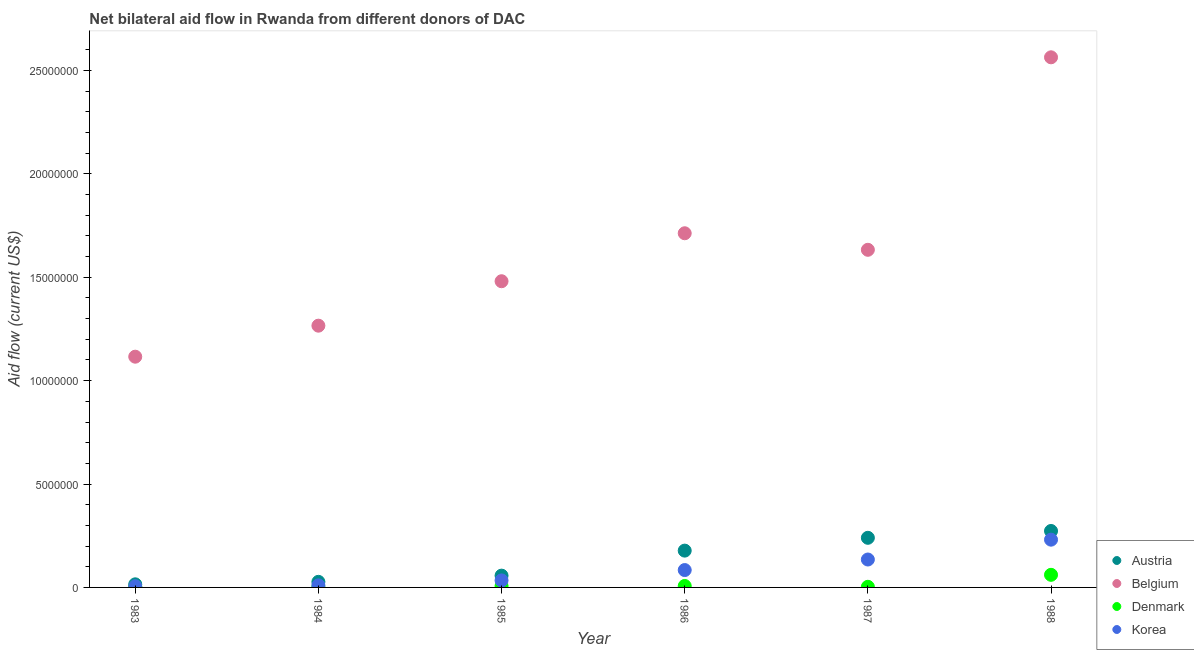Is the number of dotlines equal to the number of legend labels?
Make the answer very short. Yes. What is the amount of aid given by korea in 1985?
Provide a succinct answer. 3.40e+05. Across all years, what is the maximum amount of aid given by belgium?
Offer a terse response. 2.56e+07. Across all years, what is the minimum amount of aid given by korea?
Your answer should be very brief. 6.00e+04. In which year was the amount of aid given by austria maximum?
Keep it short and to the point. 1988. In which year was the amount of aid given by korea minimum?
Offer a terse response. 1983. What is the total amount of aid given by austria in the graph?
Your answer should be very brief. 7.90e+06. What is the difference between the amount of aid given by austria in 1984 and that in 1985?
Your answer should be very brief. -3.00e+05. What is the difference between the amount of aid given by denmark in 1987 and the amount of aid given by korea in 1986?
Your answer should be compact. -8.10e+05. What is the average amount of aid given by denmark per year?
Ensure brevity in your answer.  1.40e+05. In the year 1987, what is the difference between the amount of aid given by belgium and amount of aid given by denmark?
Provide a succinct answer. 1.63e+07. In how many years, is the amount of aid given by denmark greater than 18000000 US$?
Give a very brief answer. 0. What is the ratio of the amount of aid given by denmark in 1985 to that in 1988?
Give a very brief answer. 0.11. Is the difference between the amount of aid given by austria in 1983 and 1984 greater than the difference between the amount of aid given by belgium in 1983 and 1984?
Keep it short and to the point. Yes. What is the difference between the highest and the second highest amount of aid given by belgium?
Keep it short and to the point. 8.51e+06. What is the difference between the highest and the lowest amount of aid given by austria?
Provide a short and direct response. 2.58e+06. In how many years, is the amount of aid given by korea greater than the average amount of aid given by korea taken over all years?
Offer a terse response. 3. Is the amount of aid given by korea strictly greater than the amount of aid given by denmark over the years?
Provide a short and direct response. Yes. Does the graph contain grids?
Keep it short and to the point. No. Where does the legend appear in the graph?
Ensure brevity in your answer.  Bottom right. What is the title of the graph?
Ensure brevity in your answer.  Net bilateral aid flow in Rwanda from different donors of DAC. Does "Portugal" appear as one of the legend labels in the graph?
Your response must be concise. No. What is the label or title of the X-axis?
Your response must be concise. Year. What is the label or title of the Y-axis?
Make the answer very short. Aid flow (current US$). What is the Aid flow (current US$) of Belgium in 1983?
Provide a succinct answer. 1.12e+07. What is the Aid flow (current US$) in Denmark in 1983?
Your answer should be compact. 4.00e+04. What is the Aid flow (current US$) in Korea in 1983?
Offer a terse response. 6.00e+04. What is the Aid flow (current US$) of Austria in 1984?
Provide a short and direct response. 2.70e+05. What is the Aid flow (current US$) of Belgium in 1984?
Give a very brief answer. 1.27e+07. What is the Aid flow (current US$) in Denmark in 1984?
Provide a short and direct response. 2.00e+04. What is the Aid flow (current US$) of Austria in 1985?
Your answer should be very brief. 5.70e+05. What is the Aid flow (current US$) of Belgium in 1985?
Provide a short and direct response. 1.48e+07. What is the Aid flow (current US$) of Korea in 1985?
Your response must be concise. 3.40e+05. What is the Aid flow (current US$) in Austria in 1986?
Make the answer very short. 1.78e+06. What is the Aid flow (current US$) of Belgium in 1986?
Provide a succinct answer. 1.71e+07. What is the Aid flow (current US$) of Denmark in 1986?
Keep it short and to the point. 7.00e+04. What is the Aid flow (current US$) in Korea in 1986?
Provide a short and direct response. 8.40e+05. What is the Aid flow (current US$) of Austria in 1987?
Your answer should be compact. 2.40e+06. What is the Aid flow (current US$) in Belgium in 1987?
Provide a short and direct response. 1.63e+07. What is the Aid flow (current US$) in Korea in 1987?
Keep it short and to the point. 1.35e+06. What is the Aid flow (current US$) in Austria in 1988?
Your answer should be very brief. 2.73e+06. What is the Aid flow (current US$) in Belgium in 1988?
Your answer should be very brief. 2.56e+07. What is the Aid flow (current US$) in Denmark in 1988?
Offer a very short reply. 6.10e+05. What is the Aid flow (current US$) in Korea in 1988?
Provide a succinct answer. 2.31e+06. Across all years, what is the maximum Aid flow (current US$) of Austria?
Your answer should be compact. 2.73e+06. Across all years, what is the maximum Aid flow (current US$) of Belgium?
Offer a very short reply. 2.56e+07. Across all years, what is the maximum Aid flow (current US$) in Korea?
Provide a succinct answer. 2.31e+06. Across all years, what is the minimum Aid flow (current US$) of Belgium?
Your answer should be very brief. 1.12e+07. Across all years, what is the minimum Aid flow (current US$) in Denmark?
Provide a short and direct response. 2.00e+04. Across all years, what is the minimum Aid flow (current US$) of Korea?
Keep it short and to the point. 6.00e+04. What is the total Aid flow (current US$) of Austria in the graph?
Your answer should be very brief. 7.90e+06. What is the total Aid flow (current US$) of Belgium in the graph?
Make the answer very short. 9.77e+07. What is the total Aid flow (current US$) in Denmark in the graph?
Ensure brevity in your answer.  8.40e+05. What is the total Aid flow (current US$) in Korea in the graph?
Make the answer very short. 5.00e+06. What is the difference between the Aid flow (current US$) in Austria in 1983 and that in 1984?
Ensure brevity in your answer.  -1.20e+05. What is the difference between the Aid flow (current US$) of Belgium in 1983 and that in 1984?
Make the answer very short. -1.50e+06. What is the difference between the Aid flow (current US$) in Denmark in 1983 and that in 1984?
Your answer should be compact. 2.00e+04. What is the difference between the Aid flow (current US$) in Austria in 1983 and that in 1985?
Your response must be concise. -4.20e+05. What is the difference between the Aid flow (current US$) of Belgium in 1983 and that in 1985?
Provide a succinct answer. -3.65e+06. What is the difference between the Aid flow (current US$) in Korea in 1983 and that in 1985?
Give a very brief answer. -2.80e+05. What is the difference between the Aid flow (current US$) in Austria in 1983 and that in 1986?
Provide a short and direct response. -1.63e+06. What is the difference between the Aid flow (current US$) in Belgium in 1983 and that in 1986?
Ensure brevity in your answer.  -5.97e+06. What is the difference between the Aid flow (current US$) of Korea in 1983 and that in 1986?
Your answer should be compact. -7.80e+05. What is the difference between the Aid flow (current US$) of Austria in 1983 and that in 1987?
Your answer should be very brief. -2.25e+06. What is the difference between the Aid flow (current US$) of Belgium in 1983 and that in 1987?
Your answer should be compact. -5.17e+06. What is the difference between the Aid flow (current US$) of Korea in 1983 and that in 1987?
Provide a short and direct response. -1.29e+06. What is the difference between the Aid flow (current US$) in Austria in 1983 and that in 1988?
Your response must be concise. -2.58e+06. What is the difference between the Aid flow (current US$) of Belgium in 1983 and that in 1988?
Provide a short and direct response. -1.45e+07. What is the difference between the Aid flow (current US$) in Denmark in 1983 and that in 1988?
Make the answer very short. -5.70e+05. What is the difference between the Aid flow (current US$) in Korea in 1983 and that in 1988?
Provide a succinct answer. -2.25e+06. What is the difference between the Aid flow (current US$) in Austria in 1984 and that in 1985?
Provide a succinct answer. -3.00e+05. What is the difference between the Aid flow (current US$) in Belgium in 1984 and that in 1985?
Your response must be concise. -2.15e+06. What is the difference between the Aid flow (current US$) in Denmark in 1984 and that in 1985?
Give a very brief answer. -5.00e+04. What is the difference between the Aid flow (current US$) of Korea in 1984 and that in 1985?
Give a very brief answer. -2.40e+05. What is the difference between the Aid flow (current US$) of Austria in 1984 and that in 1986?
Offer a very short reply. -1.51e+06. What is the difference between the Aid flow (current US$) in Belgium in 1984 and that in 1986?
Keep it short and to the point. -4.47e+06. What is the difference between the Aid flow (current US$) in Denmark in 1984 and that in 1986?
Provide a short and direct response. -5.00e+04. What is the difference between the Aid flow (current US$) in Korea in 1984 and that in 1986?
Provide a short and direct response. -7.40e+05. What is the difference between the Aid flow (current US$) in Austria in 1984 and that in 1987?
Your answer should be compact. -2.13e+06. What is the difference between the Aid flow (current US$) in Belgium in 1984 and that in 1987?
Make the answer very short. -3.67e+06. What is the difference between the Aid flow (current US$) of Korea in 1984 and that in 1987?
Make the answer very short. -1.25e+06. What is the difference between the Aid flow (current US$) in Austria in 1984 and that in 1988?
Keep it short and to the point. -2.46e+06. What is the difference between the Aid flow (current US$) of Belgium in 1984 and that in 1988?
Offer a terse response. -1.30e+07. What is the difference between the Aid flow (current US$) in Denmark in 1984 and that in 1988?
Give a very brief answer. -5.90e+05. What is the difference between the Aid flow (current US$) in Korea in 1984 and that in 1988?
Make the answer very short. -2.21e+06. What is the difference between the Aid flow (current US$) of Austria in 1985 and that in 1986?
Keep it short and to the point. -1.21e+06. What is the difference between the Aid flow (current US$) of Belgium in 1985 and that in 1986?
Offer a terse response. -2.32e+06. What is the difference between the Aid flow (current US$) in Denmark in 1985 and that in 1986?
Your answer should be compact. 0. What is the difference between the Aid flow (current US$) of Korea in 1985 and that in 1986?
Ensure brevity in your answer.  -5.00e+05. What is the difference between the Aid flow (current US$) in Austria in 1985 and that in 1987?
Provide a succinct answer. -1.83e+06. What is the difference between the Aid flow (current US$) in Belgium in 1985 and that in 1987?
Your answer should be very brief. -1.52e+06. What is the difference between the Aid flow (current US$) in Denmark in 1985 and that in 1987?
Your answer should be very brief. 4.00e+04. What is the difference between the Aid flow (current US$) of Korea in 1985 and that in 1987?
Ensure brevity in your answer.  -1.01e+06. What is the difference between the Aid flow (current US$) in Austria in 1985 and that in 1988?
Your answer should be compact. -2.16e+06. What is the difference between the Aid flow (current US$) in Belgium in 1985 and that in 1988?
Provide a short and direct response. -1.08e+07. What is the difference between the Aid flow (current US$) in Denmark in 1985 and that in 1988?
Provide a succinct answer. -5.40e+05. What is the difference between the Aid flow (current US$) of Korea in 1985 and that in 1988?
Give a very brief answer. -1.97e+06. What is the difference between the Aid flow (current US$) in Austria in 1986 and that in 1987?
Provide a short and direct response. -6.20e+05. What is the difference between the Aid flow (current US$) of Belgium in 1986 and that in 1987?
Make the answer very short. 8.00e+05. What is the difference between the Aid flow (current US$) of Denmark in 1986 and that in 1987?
Make the answer very short. 4.00e+04. What is the difference between the Aid flow (current US$) of Korea in 1986 and that in 1987?
Your answer should be compact. -5.10e+05. What is the difference between the Aid flow (current US$) in Austria in 1986 and that in 1988?
Your response must be concise. -9.50e+05. What is the difference between the Aid flow (current US$) in Belgium in 1986 and that in 1988?
Offer a terse response. -8.51e+06. What is the difference between the Aid flow (current US$) in Denmark in 1986 and that in 1988?
Ensure brevity in your answer.  -5.40e+05. What is the difference between the Aid flow (current US$) of Korea in 1986 and that in 1988?
Provide a short and direct response. -1.47e+06. What is the difference between the Aid flow (current US$) of Austria in 1987 and that in 1988?
Make the answer very short. -3.30e+05. What is the difference between the Aid flow (current US$) in Belgium in 1987 and that in 1988?
Your answer should be very brief. -9.31e+06. What is the difference between the Aid flow (current US$) in Denmark in 1987 and that in 1988?
Provide a short and direct response. -5.80e+05. What is the difference between the Aid flow (current US$) in Korea in 1987 and that in 1988?
Make the answer very short. -9.60e+05. What is the difference between the Aid flow (current US$) in Austria in 1983 and the Aid flow (current US$) in Belgium in 1984?
Your answer should be very brief. -1.25e+07. What is the difference between the Aid flow (current US$) of Belgium in 1983 and the Aid flow (current US$) of Denmark in 1984?
Your answer should be compact. 1.11e+07. What is the difference between the Aid flow (current US$) in Belgium in 1983 and the Aid flow (current US$) in Korea in 1984?
Your response must be concise. 1.11e+07. What is the difference between the Aid flow (current US$) of Austria in 1983 and the Aid flow (current US$) of Belgium in 1985?
Your response must be concise. -1.47e+07. What is the difference between the Aid flow (current US$) of Belgium in 1983 and the Aid flow (current US$) of Denmark in 1985?
Your response must be concise. 1.11e+07. What is the difference between the Aid flow (current US$) of Belgium in 1983 and the Aid flow (current US$) of Korea in 1985?
Offer a terse response. 1.08e+07. What is the difference between the Aid flow (current US$) of Austria in 1983 and the Aid flow (current US$) of Belgium in 1986?
Keep it short and to the point. -1.70e+07. What is the difference between the Aid flow (current US$) in Austria in 1983 and the Aid flow (current US$) in Korea in 1986?
Keep it short and to the point. -6.90e+05. What is the difference between the Aid flow (current US$) of Belgium in 1983 and the Aid flow (current US$) of Denmark in 1986?
Give a very brief answer. 1.11e+07. What is the difference between the Aid flow (current US$) in Belgium in 1983 and the Aid flow (current US$) in Korea in 1986?
Ensure brevity in your answer.  1.03e+07. What is the difference between the Aid flow (current US$) in Denmark in 1983 and the Aid flow (current US$) in Korea in 1986?
Your answer should be compact. -8.00e+05. What is the difference between the Aid flow (current US$) in Austria in 1983 and the Aid flow (current US$) in Belgium in 1987?
Provide a succinct answer. -1.62e+07. What is the difference between the Aid flow (current US$) of Austria in 1983 and the Aid flow (current US$) of Denmark in 1987?
Offer a terse response. 1.20e+05. What is the difference between the Aid flow (current US$) in Austria in 1983 and the Aid flow (current US$) in Korea in 1987?
Keep it short and to the point. -1.20e+06. What is the difference between the Aid flow (current US$) in Belgium in 1983 and the Aid flow (current US$) in Denmark in 1987?
Provide a succinct answer. 1.11e+07. What is the difference between the Aid flow (current US$) of Belgium in 1983 and the Aid flow (current US$) of Korea in 1987?
Your answer should be very brief. 9.81e+06. What is the difference between the Aid flow (current US$) of Denmark in 1983 and the Aid flow (current US$) of Korea in 1987?
Your response must be concise. -1.31e+06. What is the difference between the Aid flow (current US$) of Austria in 1983 and the Aid flow (current US$) of Belgium in 1988?
Keep it short and to the point. -2.55e+07. What is the difference between the Aid flow (current US$) of Austria in 1983 and the Aid flow (current US$) of Denmark in 1988?
Your response must be concise. -4.60e+05. What is the difference between the Aid flow (current US$) of Austria in 1983 and the Aid flow (current US$) of Korea in 1988?
Ensure brevity in your answer.  -2.16e+06. What is the difference between the Aid flow (current US$) of Belgium in 1983 and the Aid flow (current US$) of Denmark in 1988?
Your answer should be compact. 1.06e+07. What is the difference between the Aid flow (current US$) of Belgium in 1983 and the Aid flow (current US$) of Korea in 1988?
Keep it short and to the point. 8.85e+06. What is the difference between the Aid flow (current US$) of Denmark in 1983 and the Aid flow (current US$) of Korea in 1988?
Ensure brevity in your answer.  -2.27e+06. What is the difference between the Aid flow (current US$) in Austria in 1984 and the Aid flow (current US$) in Belgium in 1985?
Ensure brevity in your answer.  -1.45e+07. What is the difference between the Aid flow (current US$) in Belgium in 1984 and the Aid flow (current US$) in Denmark in 1985?
Provide a succinct answer. 1.26e+07. What is the difference between the Aid flow (current US$) in Belgium in 1984 and the Aid flow (current US$) in Korea in 1985?
Offer a terse response. 1.23e+07. What is the difference between the Aid flow (current US$) of Denmark in 1984 and the Aid flow (current US$) of Korea in 1985?
Your response must be concise. -3.20e+05. What is the difference between the Aid flow (current US$) of Austria in 1984 and the Aid flow (current US$) of Belgium in 1986?
Make the answer very short. -1.69e+07. What is the difference between the Aid flow (current US$) of Austria in 1984 and the Aid flow (current US$) of Korea in 1986?
Give a very brief answer. -5.70e+05. What is the difference between the Aid flow (current US$) of Belgium in 1984 and the Aid flow (current US$) of Denmark in 1986?
Give a very brief answer. 1.26e+07. What is the difference between the Aid flow (current US$) of Belgium in 1984 and the Aid flow (current US$) of Korea in 1986?
Provide a short and direct response. 1.18e+07. What is the difference between the Aid flow (current US$) in Denmark in 1984 and the Aid flow (current US$) in Korea in 1986?
Your answer should be very brief. -8.20e+05. What is the difference between the Aid flow (current US$) in Austria in 1984 and the Aid flow (current US$) in Belgium in 1987?
Make the answer very short. -1.61e+07. What is the difference between the Aid flow (current US$) in Austria in 1984 and the Aid flow (current US$) in Denmark in 1987?
Your answer should be compact. 2.40e+05. What is the difference between the Aid flow (current US$) of Austria in 1984 and the Aid flow (current US$) of Korea in 1987?
Your response must be concise. -1.08e+06. What is the difference between the Aid flow (current US$) of Belgium in 1984 and the Aid flow (current US$) of Denmark in 1987?
Ensure brevity in your answer.  1.26e+07. What is the difference between the Aid flow (current US$) of Belgium in 1984 and the Aid flow (current US$) of Korea in 1987?
Offer a terse response. 1.13e+07. What is the difference between the Aid flow (current US$) in Denmark in 1984 and the Aid flow (current US$) in Korea in 1987?
Ensure brevity in your answer.  -1.33e+06. What is the difference between the Aid flow (current US$) in Austria in 1984 and the Aid flow (current US$) in Belgium in 1988?
Give a very brief answer. -2.54e+07. What is the difference between the Aid flow (current US$) in Austria in 1984 and the Aid flow (current US$) in Denmark in 1988?
Ensure brevity in your answer.  -3.40e+05. What is the difference between the Aid flow (current US$) of Austria in 1984 and the Aid flow (current US$) of Korea in 1988?
Your answer should be very brief. -2.04e+06. What is the difference between the Aid flow (current US$) of Belgium in 1984 and the Aid flow (current US$) of Denmark in 1988?
Offer a very short reply. 1.20e+07. What is the difference between the Aid flow (current US$) in Belgium in 1984 and the Aid flow (current US$) in Korea in 1988?
Make the answer very short. 1.04e+07. What is the difference between the Aid flow (current US$) in Denmark in 1984 and the Aid flow (current US$) in Korea in 1988?
Give a very brief answer. -2.29e+06. What is the difference between the Aid flow (current US$) of Austria in 1985 and the Aid flow (current US$) of Belgium in 1986?
Your answer should be very brief. -1.66e+07. What is the difference between the Aid flow (current US$) in Austria in 1985 and the Aid flow (current US$) in Denmark in 1986?
Provide a succinct answer. 5.00e+05. What is the difference between the Aid flow (current US$) in Belgium in 1985 and the Aid flow (current US$) in Denmark in 1986?
Make the answer very short. 1.47e+07. What is the difference between the Aid flow (current US$) of Belgium in 1985 and the Aid flow (current US$) of Korea in 1986?
Make the answer very short. 1.40e+07. What is the difference between the Aid flow (current US$) in Denmark in 1985 and the Aid flow (current US$) in Korea in 1986?
Provide a short and direct response. -7.70e+05. What is the difference between the Aid flow (current US$) of Austria in 1985 and the Aid flow (current US$) of Belgium in 1987?
Offer a very short reply. -1.58e+07. What is the difference between the Aid flow (current US$) in Austria in 1985 and the Aid flow (current US$) in Denmark in 1987?
Make the answer very short. 5.40e+05. What is the difference between the Aid flow (current US$) in Austria in 1985 and the Aid flow (current US$) in Korea in 1987?
Offer a very short reply. -7.80e+05. What is the difference between the Aid flow (current US$) in Belgium in 1985 and the Aid flow (current US$) in Denmark in 1987?
Keep it short and to the point. 1.48e+07. What is the difference between the Aid flow (current US$) of Belgium in 1985 and the Aid flow (current US$) of Korea in 1987?
Give a very brief answer. 1.35e+07. What is the difference between the Aid flow (current US$) of Denmark in 1985 and the Aid flow (current US$) of Korea in 1987?
Keep it short and to the point. -1.28e+06. What is the difference between the Aid flow (current US$) in Austria in 1985 and the Aid flow (current US$) in Belgium in 1988?
Keep it short and to the point. -2.51e+07. What is the difference between the Aid flow (current US$) in Austria in 1985 and the Aid flow (current US$) in Denmark in 1988?
Your answer should be very brief. -4.00e+04. What is the difference between the Aid flow (current US$) of Austria in 1985 and the Aid flow (current US$) of Korea in 1988?
Keep it short and to the point. -1.74e+06. What is the difference between the Aid flow (current US$) of Belgium in 1985 and the Aid flow (current US$) of Denmark in 1988?
Offer a very short reply. 1.42e+07. What is the difference between the Aid flow (current US$) in Belgium in 1985 and the Aid flow (current US$) in Korea in 1988?
Offer a very short reply. 1.25e+07. What is the difference between the Aid flow (current US$) in Denmark in 1985 and the Aid flow (current US$) in Korea in 1988?
Give a very brief answer. -2.24e+06. What is the difference between the Aid flow (current US$) in Austria in 1986 and the Aid flow (current US$) in Belgium in 1987?
Your response must be concise. -1.46e+07. What is the difference between the Aid flow (current US$) in Austria in 1986 and the Aid flow (current US$) in Denmark in 1987?
Offer a terse response. 1.75e+06. What is the difference between the Aid flow (current US$) of Belgium in 1986 and the Aid flow (current US$) of Denmark in 1987?
Make the answer very short. 1.71e+07. What is the difference between the Aid flow (current US$) of Belgium in 1986 and the Aid flow (current US$) of Korea in 1987?
Your answer should be compact. 1.58e+07. What is the difference between the Aid flow (current US$) of Denmark in 1986 and the Aid flow (current US$) of Korea in 1987?
Provide a succinct answer. -1.28e+06. What is the difference between the Aid flow (current US$) in Austria in 1986 and the Aid flow (current US$) in Belgium in 1988?
Offer a very short reply. -2.39e+07. What is the difference between the Aid flow (current US$) of Austria in 1986 and the Aid flow (current US$) of Denmark in 1988?
Your answer should be compact. 1.17e+06. What is the difference between the Aid flow (current US$) of Austria in 1986 and the Aid flow (current US$) of Korea in 1988?
Offer a very short reply. -5.30e+05. What is the difference between the Aid flow (current US$) in Belgium in 1986 and the Aid flow (current US$) in Denmark in 1988?
Your response must be concise. 1.65e+07. What is the difference between the Aid flow (current US$) in Belgium in 1986 and the Aid flow (current US$) in Korea in 1988?
Your response must be concise. 1.48e+07. What is the difference between the Aid flow (current US$) of Denmark in 1986 and the Aid flow (current US$) of Korea in 1988?
Provide a short and direct response. -2.24e+06. What is the difference between the Aid flow (current US$) in Austria in 1987 and the Aid flow (current US$) in Belgium in 1988?
Provide a succinct answer. -2.32e+07. What is the difference between the Aid flow (current US$) in Austria in 1987 and the Aid flow (current US$) in Denmark in 1988?
Your response must be concise. 1.79e+06. What is the difference between the Aid flow (current US$) of Belgium in 1987 and the Aid flow (current US$) of Denmark in 1988?
Ensure brevity in your answer.  1.57e+07. What is the difference between the Aid flow (current US$) of Belgium in 1987 and the Aid flow (current US$) of Korea in 1988?
Your answer should be compact. 1.40e+07. What is the difference between the Aid flow (current US$) in Denmark in 1987 and the Aid flow (current US$) in Korea in 1988?
Your answer should be compact. -2.28e+06. What is the average Aid flow (current US$) in Austria per year?
Ensure brevity in your answer.  1.32e+06. What is the average Aid flow (current US$) of Belgium per year?
Make the answer very short. 1.63e+07. What is the average Aid flow (current US$) in Denmark per year?
Provide a succinct answer. 1.40e+05. What is the average Aid flow (current US$) of Korea per year?
Your answer should be compact. 8.33e+05. In the year 1983, what is the difference between the Aid flow (current US$) in Austria and Aid flow (current US$) in Belgium?
Offer a terse response. -1.10e+07. In the year 1983, what is the difference between the Aid flow (current US$) in Austria and Aid flow (current US$) in Denmark?
Make the answer very short. 1.10e+05. In the year 1983, what is the difference between the Aid flow (current US$) in Austria and Aid flow (current US$) in Korea?
Your answer should be very brief. 9.00e+04. In the year 1983, what is the difference between the Aid flow (current US$) in Belgium and Aid flow (current US$) in Denmark?
Provide a succinct answer. 1.11e+07. In the year 1983, what is the difference between the Aid flow (current US$) of Belgium and Aid flow (current US$) of Korea?
Offer a very short reply. 1.11e+07. In the year 1983, what is the difference between the Aid flow (current US$) of Denmark and Aid flow (current US$) of Korea?
Your answer should be very brief. -2.00e+04. In the year 1984, what is the difference between the Aid flow (current US$) of Austria and Aid flow (current US$) of Belgium?
Provide a short and direct response. -1.24e+07. In the year 1984, what is the difference between the Aid flow (current US$) in Austria and Aid flow (current US$) in Denmark?
Offer a very short reply. 2.50e+05. In the year 1984, what is the difference between the Aid flow (current US$) of Belgium and Aid flow (current US$) of Denmark?
Offer a terse response. 1.26e+07. In the year 1984, what is the difference between the Aid flow (current US$) of Belgium and Aid flow (current US$) of Korea?
Offer a very short reply. 1.26e+07. In the year 1984, what is the difference between the Aid flow (current US$) in Denmark and Aid flow (current US$) in Korea?
Offer a very short reply. -8.00e+04. In the year 1985, what is the difference between the Aid flow (current US$) of Austria and Aid flow (current US$) of Belgium?
Make the answer very short. -1.42e+07. In the year 1985, what is the difference between the Aid flow (current US$) in Belgium and Aid flow (current US$) in Denmark?
Your answer should be compact. 1.47e+07. In the year 1985, what is the difference between the Aid flow (current US$) of Belgium and Aid flow (current US$) of Korea?
Your answer should be very brief. 1.45e+07. In the year 1986, what is the difference between the Aid flow (current US$) of Austria and Aid flow (current US$) of Belgium?
Ensure brevity in your answer.  -1.54e+07. In the year 1986, what is the difference between the Aid flow (current US$) in Austria and Aid flow (current US$) in Denmark?
Make the answer very short. 1.71e+06. In the year 1986, what is the difference between the Aid flow (current US$) of Austria and Aid flow (current US$) of Korea?
Offer a very short reply. 9.40e+05. In the year 1986, what is the difference between the Aid flow (current US$) in Belgium and Aid flow (current US$) in Denmark?
Provide a short and direct response. 1.71e+07. In the year 1986, what is the difference between the Aid flow (current US$) in Belgium and Aid flow (current US$) in Korea?
Your answer should be very brief. 1.63e+07. In the year 1986, what is the difference between the Aid flow (current US$) in Denmark and Aid flow (current US$) in Korea?
Provide a short and direct response. -7.70e+05. In the year 1987, what is the difference between the Aid flow (current US$) in Austria and Aid flow (current US$) in Belgium?
Offer a terse response. -1.39e+07. In the year 1987, what is the difference between the Aid flow (current US$) in Austria and Aid flow (current US$) in Denmark?
Your answer should be compact. 2.37e+06. In the year 1987, what is the difference between the Aid flow (current US$) of Austria and Aid flow (current US$) of Korea?
Offer a very short reply. 1.05e+06. In the year 1987, what is the difference between the Aid flow (current US$) in Belgium and Aid flow (current US$) in Denmark?
Your answer should be compact. 1.63e+07. In the year 1987, what is the difference between the Aid flow (current US$) of Belgium and Aid flow (current US$) of Korea?
Your response must be concise. 1.50e+07. In the year 1987, what is the difference between the Aid flow (current US$) of Denmark and Aid flow (current US$) of Korea?
Offer a very short reply. -1.32e+06. In the year 1988, what is the difference between the Aid flow (current US$) of Austria and Aid flow (current US$) of Belgium?
Your answer should be very brief. -2.29e+07. In the year 1988, what is the difference between the Aid flow (current US$) of Austria and Aid flow (current US$) of Denmark?
Keep it short and to the point. 2.12e+06. In the year 1988, what is the difference between the Aid flow (current US$) of Belgium and Aid flow (current US$) of Denmark?
Your answer should be very brief. 2.50e+07. In the year 1988, what is the difference between the Aid flow (current US$) of Belgium and Aid flow (current US$) of Korea?
Keep it short and to the point. 2.33e+07. In the year 1988, what is the difference between the Aid flow (current US$) in Denmark and Aid flow (current US$) in Korea?
Your answer should be compact. -1.70e+06. What is the ratio of the Aid flow (current US$) of Austria in 1983 to that in 1984?
Keep it short and to the point. 0.56. What is the ratio of the Aid flow (current US$) of Belgium in 1983 to that in 1984?
Your answer should be very brief. 0.88. What is the ratio of the Aid flow (current US$) in Korea in 1983 to that in 1984?
Offer a very short reply. 0.6. What is the ratio of the Aid flow (current US$) of Austria in 1983 to that in 1985?
Ensure brevity in your answer.  0.26. What is the ratio of the Aid flow (current US$) of Belgium in 1983 to that in 1985?
Make the answer very short. 0.75. What is the ratio of the Aid flow (current US$) in Denmark in 1983 to that in 1985?
Provide a succinct answer. 0.57. What is the ratio of the Aid flow (current US$) in Korea in 1983 to that in 1985?
Your answer should be compact. 0.18. What is the ratio of the Aid flow (current US$) in Austria in 1983 to that in 1986?
Provide a succinct answer. 0.08. What is the ratio of the Aid flow (current US$) in Belgium in 1983 to that in 1986?
Your answer should be compact. 0.65. What is the ratio of the Aid flow (current US$) in Korea in 1983 to that in 1986?
Offer a very short reply. 0.07. What is the ratio of the Aid flow (current US$) in Austria in 1983 to that in 1987?
Provide a succinct answer. 0.06. What is the ratio of the Aid flow (current US$) in Belgium in 1983 to that in 1987?
Make the answer very short. 0.68. What is the ratio of the Aid flow (current US$) of Korea in 1983 to that in 1987?
Provide a short and direct response. 0.04. What is the ratio of the Aid flow (current US$) in Austria in 1983 to that in 1988?
Offer a very short reply. 0.05. What is the ratio of the Aid flow (current US$) in Belgium in 1983 to that in 1988?
Your answer should be very brief. 0.44. What is the ratio of the Aid flow (current US$) of Denmark in 1983 to that in 1988?
Offer a terse response. 0.07. What is the ratio of the Aid flow (current US$) of Korea in 1983 to that in 1988?
Your answer should be compact. 0.03. What is the ratio of the Aid flow (current US$) of Austria in 1984 to that in 1985?
Offer a very short reply. 0.47. What is the ratio of the Aid flow (current US$) in Belgium in 1984 to that in 1985?
Keep it short and to the point. 0.85. What is the ratio of the Aid flow (current US$) in Denmark in 1984 to that in 1985?
Provide a short and direct response. 0.29. What is the ratio of the Aid flow (current US$) in Korea in 1984 to that in 1985?
Keep it short and to the point. 0.29. What is the ratio of the Aid flow (current US$) of Austria in 1984 to that in 1986?
Your answer should be very brief. 0.15. What is the ratio of the Aid flow (current US$) of Belgium in 1984 to that in 1986?
Offer a terse response. 0.74. What is the ratio of the Aid flow (current US$) of Denmark in 1984 to that in 1986?
Make the answer very short. 0.29. What is the ratio of the Aid flow (current US$) in Korea in 1984 to that in 1986?
Your response must be concise. 0.12. What is the ratio of the Aid flow (current US$) of Austria in 1984 to that in 1987?
Make the answer very short. 0.11. What is the ratio of the Aid flow (current US$) of Belgium in 1984 to that in 1987?
Your answer should be compact. 0.78. What is the ratio of the Aid flow (current US$) in Denmark in 1984 to that in 1987?
Your answer should be very brief. 0.67. What is the ratio of the Aid flow (current US$) in Korea in 1984 to that in 1987?
Your answer should be compact. 0.07. What is the ratio of the Aid flow (current US$) of Austria in 1984 to that in 1988?
Keep it short and to the point. 0.1. What is the ratio of the Aid flow (current US$) of Belgium in 1984 to that in 1988?
Make the answer very short. 0.49. What is the ratio of the Aid flow (current US$) of Denmark in 1984 to that in 1988?
Your answer should be compact. 0.03. What is the ratio of the Aid flow (current US$) of Korea in 1984 to that in 1988?
Provide a succinct answer. 0.04. What is the ratio of the Aid flow (current US$) in Austria in 1985 to that in 1986?
Offer a very short reply. 0.32. What is the ratio of the Aid flow (current US$) of Belgium in 1985 to that in 1986?
Your answer should be compact. 0.86. What is the ratio of the Aid flow (current US$) in Denmark in 1985 to that in 1986?
Provide a succinct answer. 1. What is the ratio of the Aid flow (current US$) in Korea in 1985 to that in 1986?
Offer a very short reply. 0.4. What is the ratio of the Aid flow (current US$) in Austria in 1985 to that in 1987?
Make the answer very short. 0.24. What is the ratio of the Aid flow (current US$) in Belgium in 1985 to that in 1987?
Your answer should be very brief. 0.91. What is the ratio of the Aid flow (current US$) in Denmark in 1985 to that in 1987?
Ensure brevity in your answer.  2.33. What is the ratio of the Aid flow (current US$) in Korea in 1985 to that in 1987?
Provide a succinct answer. 0.25. What is the ratio of the Aid flow (current US$) in Austria in 1985 to that in 1988?
Offer a very short reply. 0.21. What is the ratio of the Aid flow (current US$) in Belgium in 1985 to that in 1988?
Provide a short and direct response. 0.58. What is the ratio of the Aid flow (current US$) of Denmark in 1985 to that in 1988?
Your response must be concise. 0.11. What is the ratio of the Aid flow (current US$) in Korea in 1985 to that in 1988?
Your response must be concise. 0.15. What is the ratio of the Aid flow (current US$) of Austria in 1986 to that in 1987?
Provide a succinct answer. 0.74. What is the ratio of the Aid flow (current US$) in Belgium in 1986 to that in 1987?
Offer a terse response. 1.05. What is the ratio of the Aid flow (current US$) in Denmark in 1986 to that in 1987?
Ensure brevity in your answer.  2.33. What is the ratio of the Aid flow (current US$) of Korea in 1986 to that in 1987?
Offer a very short reply. 0.62. What is the ratio of the Aid flow (current US$) of Austria in 1986 to that in 1988?
Offer a terse response. 0.65. What is the ratio of the Aid flow (current US$) in Belgium in 1986 to that in 1988?
Offer a terse response. 0.67. What is the ratio of the Aid flow (current US$) of Denmark in 1986 to that in 1988?
Keep it short and to the point. 0.11. What is the ratio of the Aid flow (current US$) in Korea in 1986 to that in 1988?
Ensure brevity in your answer.  0.36. What is the ratio of the Aid flow (current US$) of Austria in 1987 to that in 1988?
Your answer should be very brief. 0.88. What is the ratio of the Aid flow (current US$) of Belgium in 1987 to that in 1988?
Make the answer very short. 0.64. What is the ratio of the Aid flow (current US$) of Denmark in 1987 to that in 1988?
Give a very brief answer. 0.05. What is the ratio of the Aid flow (current US$) of Korea in 1987 to that in 1988?
Offer a terse response. 0.58. What is the difference between the highest and the second highest Aid flow (current US$) in Austria?
Offer a very short reply. 3.30e+05. What is the difference between the highest and the second highest Aid flow (current US$) of Belgium?
Provide a succinct answer. 8.51e+06. What is the difference between the highest and the second highest Aid flow (current US$) of Denmark?
Make the answer very short. 5.40e+05. What is the difference between the highest and the second highest Aid flow (current US$) in Korea?
Give a very brief answer. 9.60e+05. What is the difference between the highest and the lowest Aid flow (current US$) of Austria?
Your response must be concise. 2.58e+06. What is the difference between the highest and the lowest Aid flow (current US$) in Belgium?
Offer a terse response. 1.45e+07. What is the difference between the highest and the lowest Aid flow (current US$) of Denmark?
Ensure brevity in your answer.  5.90e+05. What is the difference between the highest and the lowest Aid flow (current US$) in Korea?
Provide a short and direct response. 2.25e+06. 